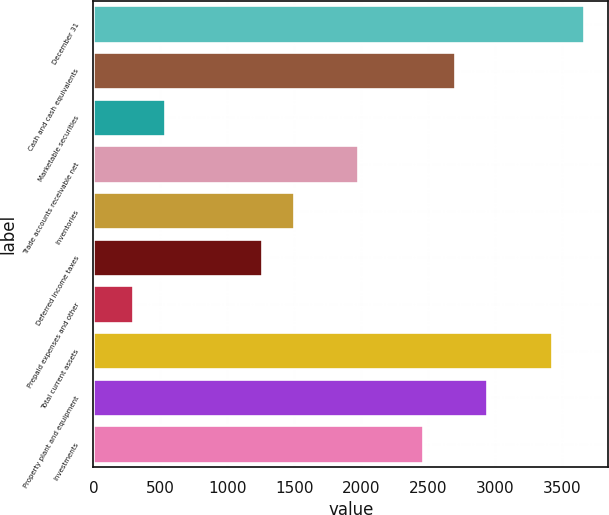Convert chart to OTSL. <chart><loc_0><loc_0><loc_500><loc_500><bar_chart><fcel>December 31<fcel>Cash and cash equivalents<fcel>Marketable securities<fcel>Trade accounts receivable net<fcel>Inventories<fcel>Deferred income taxes<fcel>Prepaid expenses and other<fcel>Total current assets<fcel>Property plant and equipment<fcel>Investments<nl><fcel>3663.5<fcel>2701.5<fcel>537<fcel>1980<fcel>1499<fcel>1258.5<fcel>296.5<fcel>3423<fcel>2942<fcel>2461<nl></chart> 